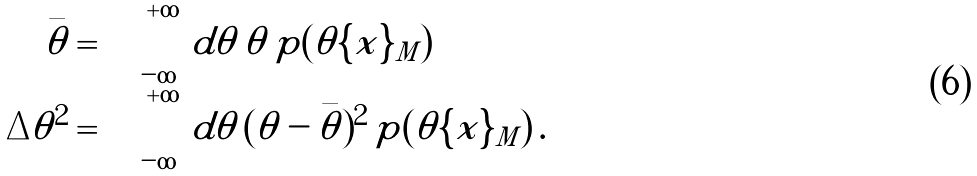<formula> <loc_0><loc_0><loc_500><loc_500>\bar { \theta } & = \int _ { - \infty } ^ { + \infty } \, d \theta \, \theta \, p ( \theta | \{ x \} _ { M } ) \\ \Delta \theta ^ { 2 } & = \int _ { - \infty } ^ { + \infty } \, d \theta \, ( \theta - \bar { \theta } ) ^ { 2 } \, p ( \theta | \{ x \} _ { M } ) \, .</formula> 